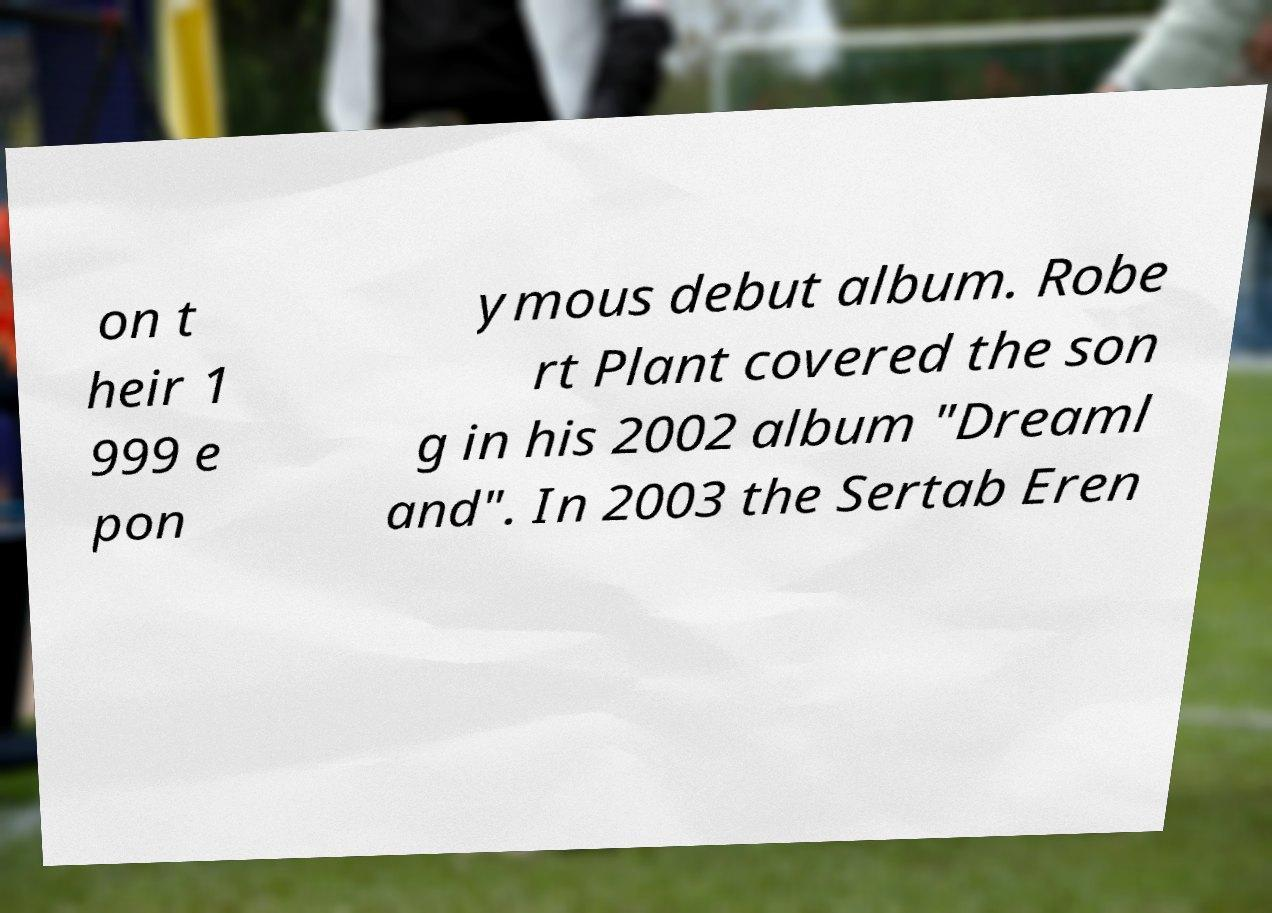I need the written content from this picture converted into text. Can you do that? on t heir 1 999 e pon ymous debut album. Robe rt Plant covered the son g in his 2002 album "Dreaml and". In 2003 the Sertab Eren 